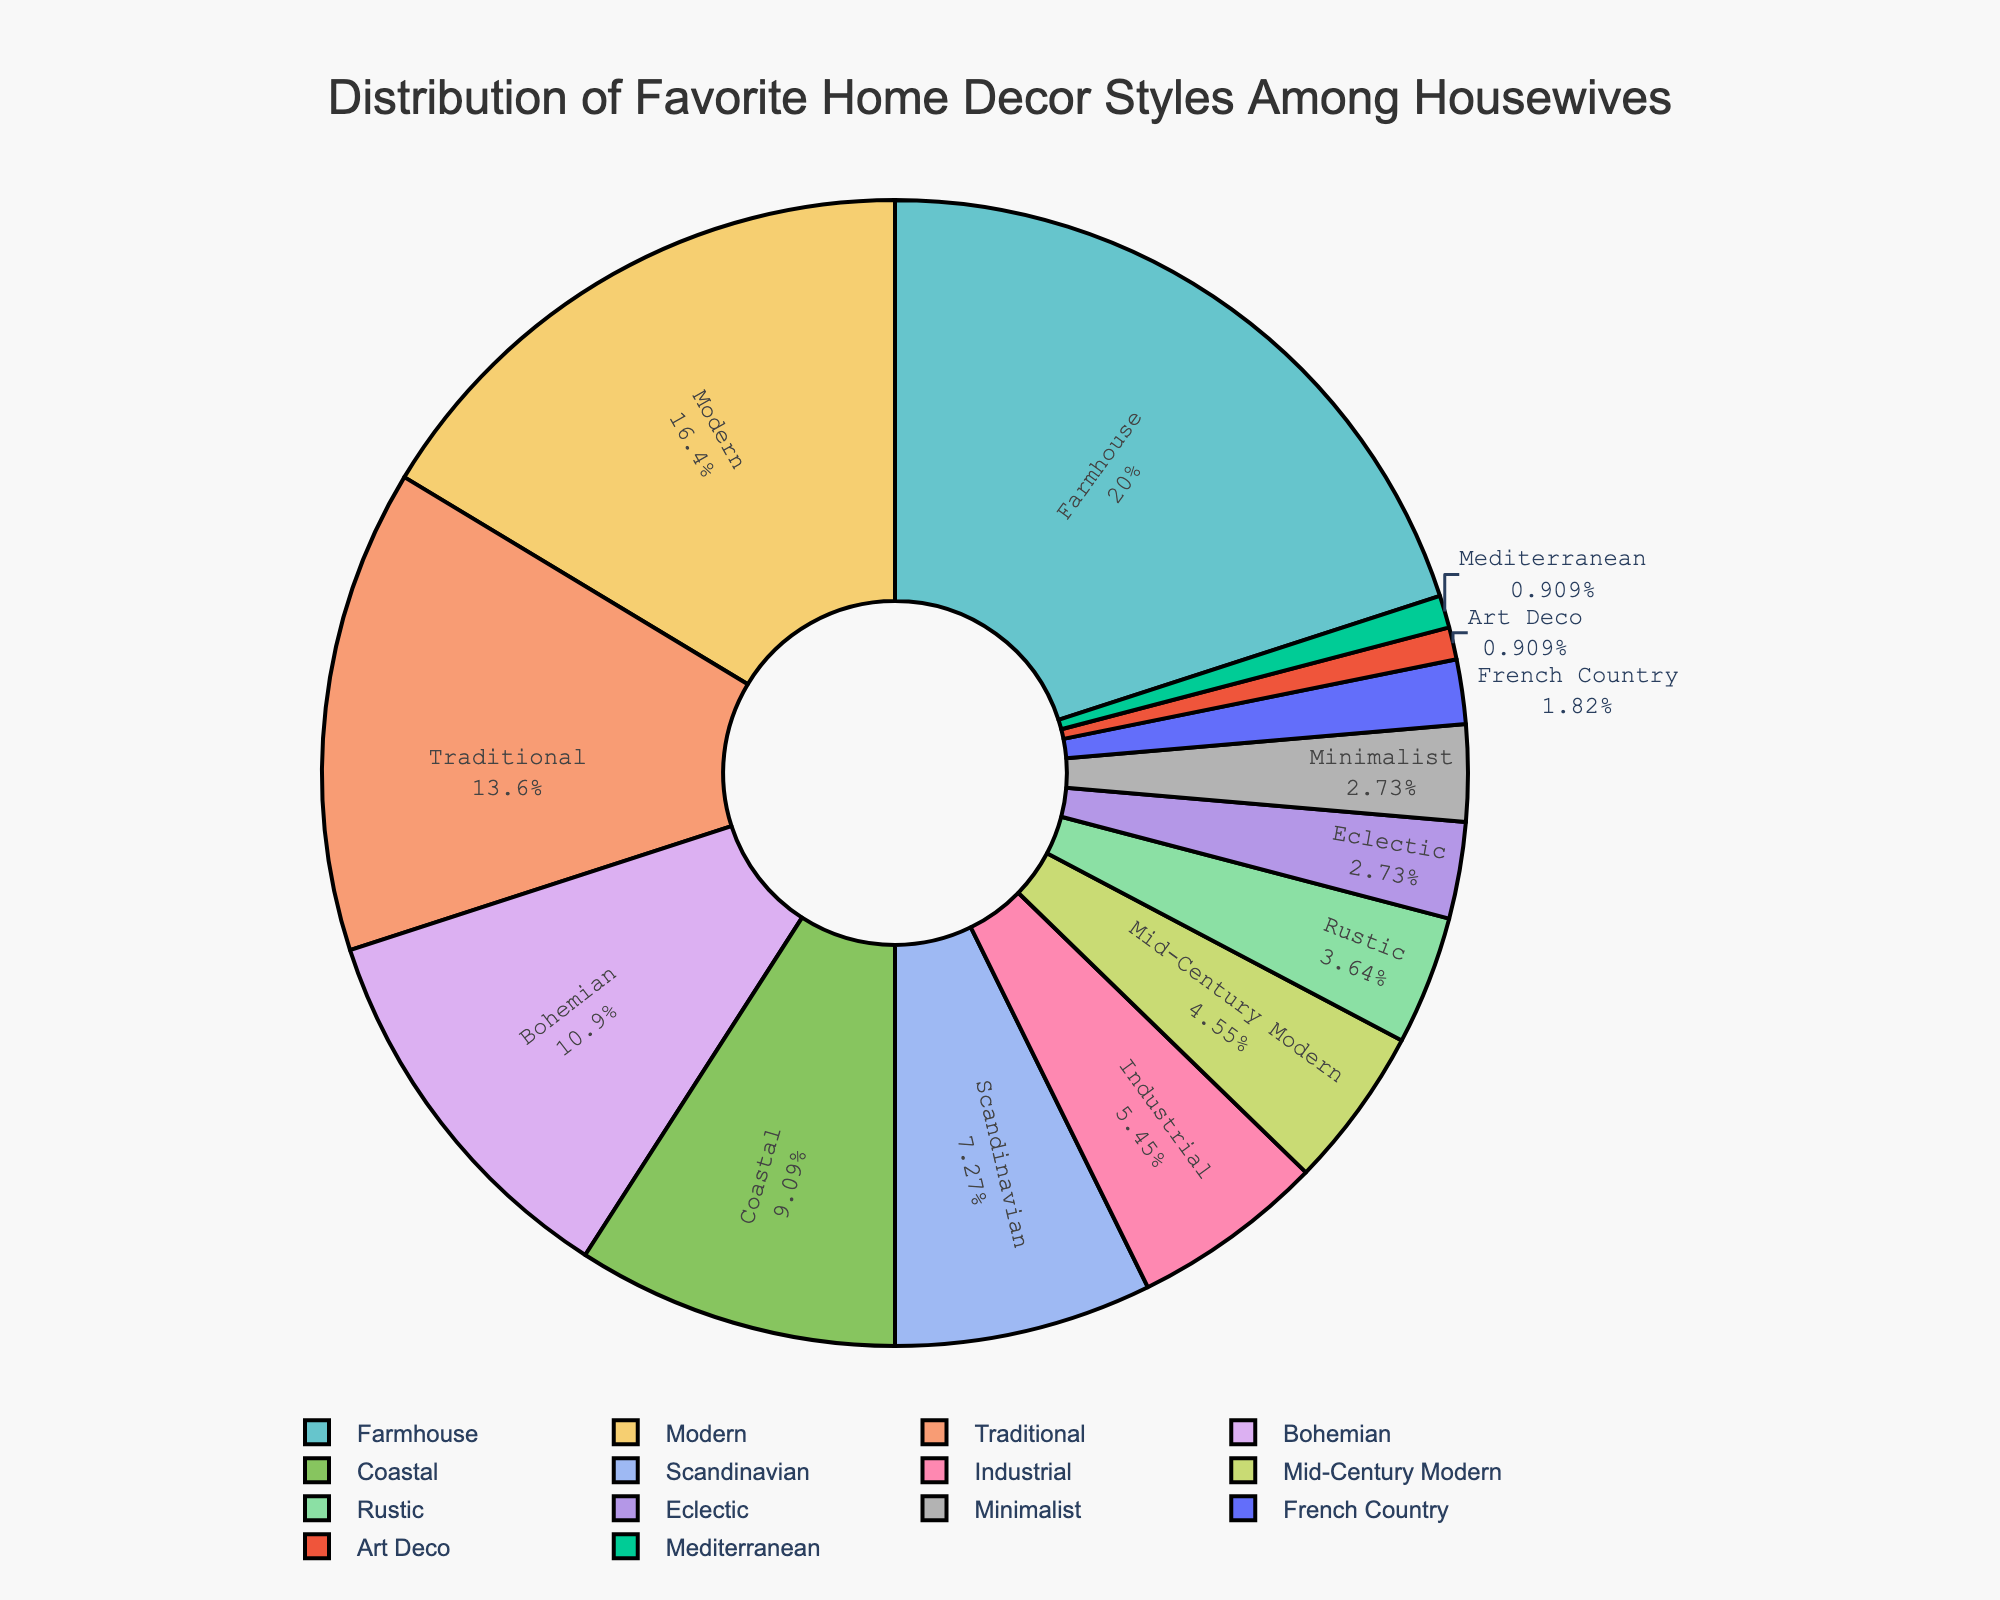Which home decor style is the most popular among housewives? The pie chart shows the different home decor styles with varying percentages of preference among housewives. The section with the highest percentage corresponds to the most popular style.
Answer: Farmhouse Which home decor styles have a preference of less than 5%? Look at the pie chart for sections labeled with percentages below 5%. These styles are near the bottom of the preference list.
Answer: Rustic, Eclectic, Minimalist, French Country, Art Deco, Mediterranean How much more popular is the Farmhouse style compared to the Industrial style? Find the percentages for Farmhouse (22%) and Industrial (6%) and calculate the difference: 22% - 6%.
Answer: 16% What is the combined percentage of Modern and Traditional styles? Find the percentages for Modern (18%) and Traditional (15%) and add them together: 18% + 15%.
Answer: 33% Which styles have a higher preference than the Coastal style? Find the percentage for Coastal (10%) and identify all styles with a higher percentage than this one.
Answer: Farmhouse, Modern, Traditional, Bohemian If you combine the percentage of Art Deco and Mediterranean styles, how does it compare to the percentage for Mid-Century Modern? Find the percentages for Art Deco (1%), Mediterranean (1%), and Mid-Century Modern (5%), then combine Art Deco and Mediterranean: 1% + 1% and compare it to Mid-Century Modern.
Answer: Mid-Century Modern is higher; 2% versus 5% Which style holds the smallest share in terms of percentage? Identify the slice of the pie chart with the smallest percentage displayed.
Answer: Art Deco, Mediterranean What is the total percentage of styles preferred by more than 10% of housewives? Identify all styles with percentages greater than 10%: Farmhouse (22%), Modern (18%), Traditional (15%), Bohemian (12%). Sum them up: 22% + 18% + 15% + 12%.
Answer: 67% Which style has a preference exactly equal to that of Minimalist? Look for the style(s) with the same percentage value as Minimalist (3%).
Answer: Eclectic What is the average percentage among all styles excluding the most and least preferred ones? Exclude Farmhouse (22%) and both Art Deco and Mediterranean (1% each), then calculate the total percentage of the remaining styles and divide by the number of these styles ((15 styles - 3 excluded) = 12). (Sum of percentages: 18 + 15 + 12 + 10 + 8 + 6 + 5 + 4 + 3 + 3 = 84; 84/12).
Answer: 7% 